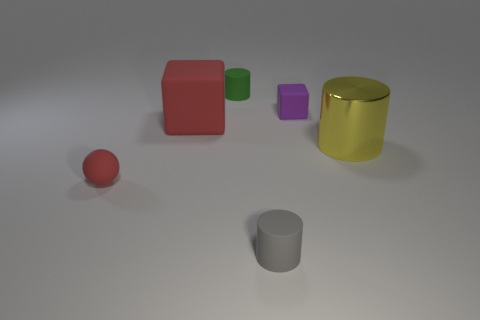Subtract all small matte cylinders. How many cylinders are left? 1 Subtract all red cubes. How many cubes are left? 1 Subtract 2 cylinders. How many cylinders are left? 1 Add 2 tiny cyan metal balls. How many objects exist? 8 Subtract all purple blocks. Subtract all red cylinders. How many blocks are left? 1 Subtract 0 gray balls. How many objects are left? 6 Subtract all blocks. How many objects are left? 4 Subtract all cyan cylinders. How many red blocks are left? 1 Subtract all green matte cylinders. Subtract all large blocks. How many objects are left? 4 Add 2 yellow things. How many yellow things are left? 3 